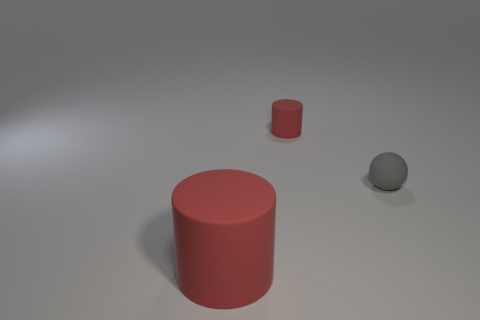The cylinder that is the same color as the large rubber object is what size?
Offer a terse response. Small. There is another thing that is the same color as the large rubber object; what is it made of?
Keep it short and to the point. Rubber. Is there any other thing that has the same size as the gray matte sphere?
Make the answer very short. Yes. Are there more tiny matte things that are behind the gray ball than tiny spheres left of the small red rubber cylinder?
Your response must be concise. Yes. What is the color of the cylinder that is right of the red thing that is on the left side of the red matte cylinder right of the large red thing?
Provide a succinct answer. Red. There is a tiny object that is behind the gray ball; is its color the same as the ball?
Provide a short and direct response. No. How many other objects are the same color as the tiny matte sphere?
Provide a succinct answer. 0. What number of objects are gray spheres or rubber things?
Your response must be concise. 3. How many objects are large matte things or rubber objects in front of the tiny rubber sphere?
Provide a succinct answer. 1. Is the tiny cylinder made of the same material as the tiny sphere?
Your response must be concise. Yes. 